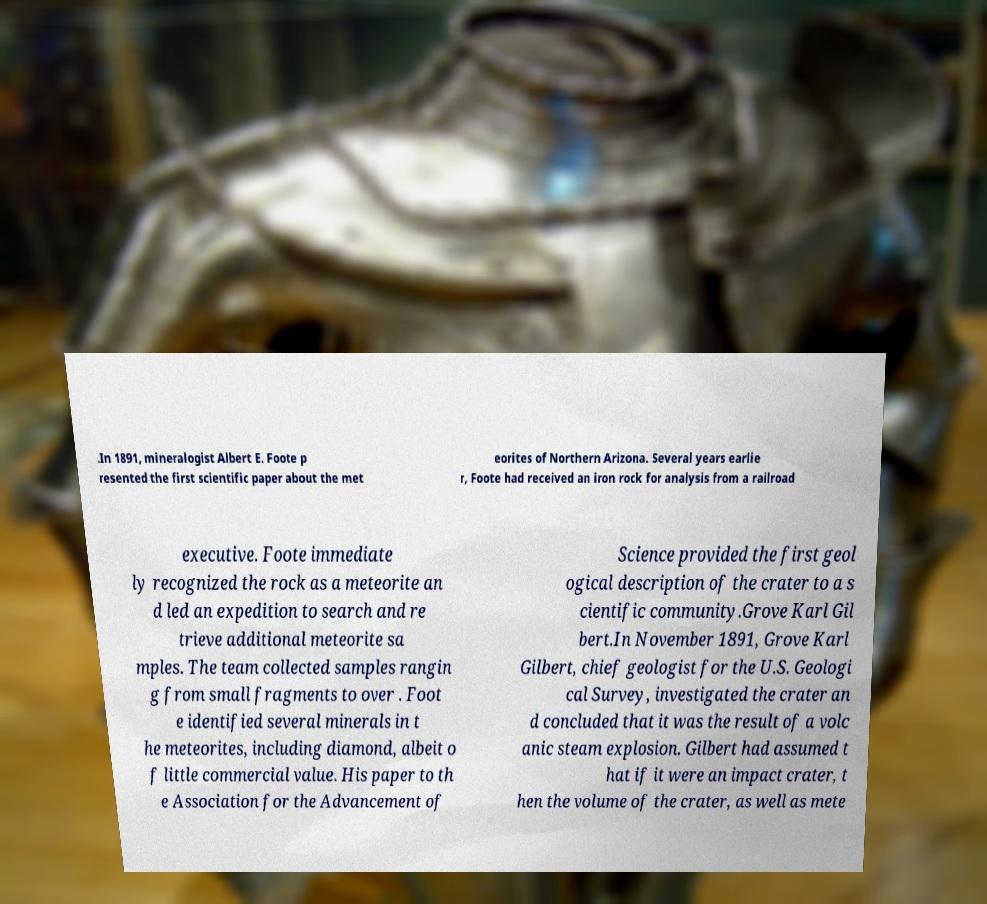For documentation purposes, I need the text within this image transcribed. Could you provide that? .In 1891, mineralogist Albert E. Foote p resented the first scientific paper about the met eorites of Northern Arizona. Several years earlie r, Foote had received an iron rock for analysis from a railroad executive. Foote immediate ly recognized the rock as a meteorite an d led an expedition to search and re trieve additional meteorite sa mples. The team collected samples rangin g from small fragments to over . Foot e identified several minerals in t he meteorites, including diamond, albeit o f little commercial value. His paper to th e Association for the Advancement of Science provided the first geol ogical description of the crater to a s cientific community.Grove Karl Gil bert.In November 1891, Grove Karl Gilbert, chief geologist for the U.S. Geologi cal Survey, investigated the crater an d concluded that it was the result of a volc anic steam explosion. Gilbert had assumed t hat if it were an impact crater, t hen the volume of the crater, as well as mete 